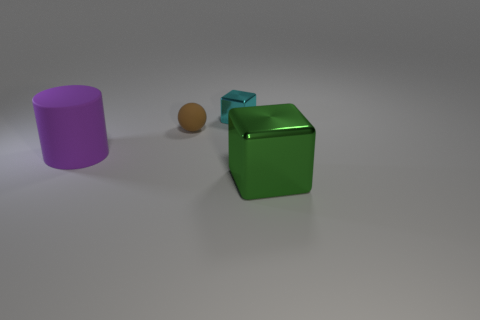What number of large objects have the same shape as the tiny rubber object?
Offer a very short reply. 0. There is a rubber object on the left side of the brown ball; is its color the same as the tiny cube?
Keep it short and to the point. No. What shape is the rubber thing that is right of the large thing behind the object that is to the right of the small metal object?
Provide a succinct answer. Sphere. Is the size of the purple cylinder the same as the metallic cube that is to the left of the big shiny block?
Offer a terse response. No. Is there a rubber thing that has the same size as the cyan metallic object?
Ensure brevity in your answer.  Yes. What number of other things are made of the same material as the purple object?
Provide a short and direct response. 1. The thing that is both in front of the cyan block and behind the purple thing is what color?
Your answer should be compact. Brown. Does the small thing that is left of the cyan shiny cube have the same material as the thing in front of the rubber cylinder?
Provide a short and direct response. No. There is a block right of the cyan metal block; is its size the same as the large purple rubber object?
Provide a succinct answer. Yes. What is the shape of the big purple rubber thing?
Your answer should be compact. Cylinder. 